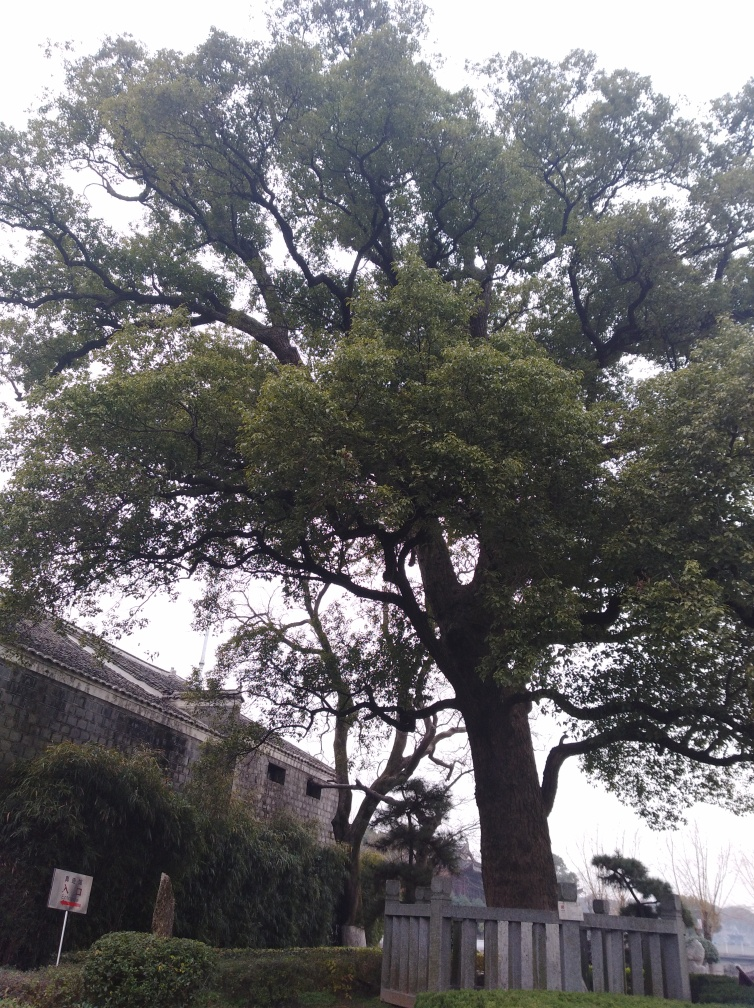What time of day does this photo seem to have been taken? Based on the lighting and shadows present in the image, it appears to have been taken during the daytime, potentially in the morning or late afternoon when the sun is not at its peak, which would explain the softness of the light. 